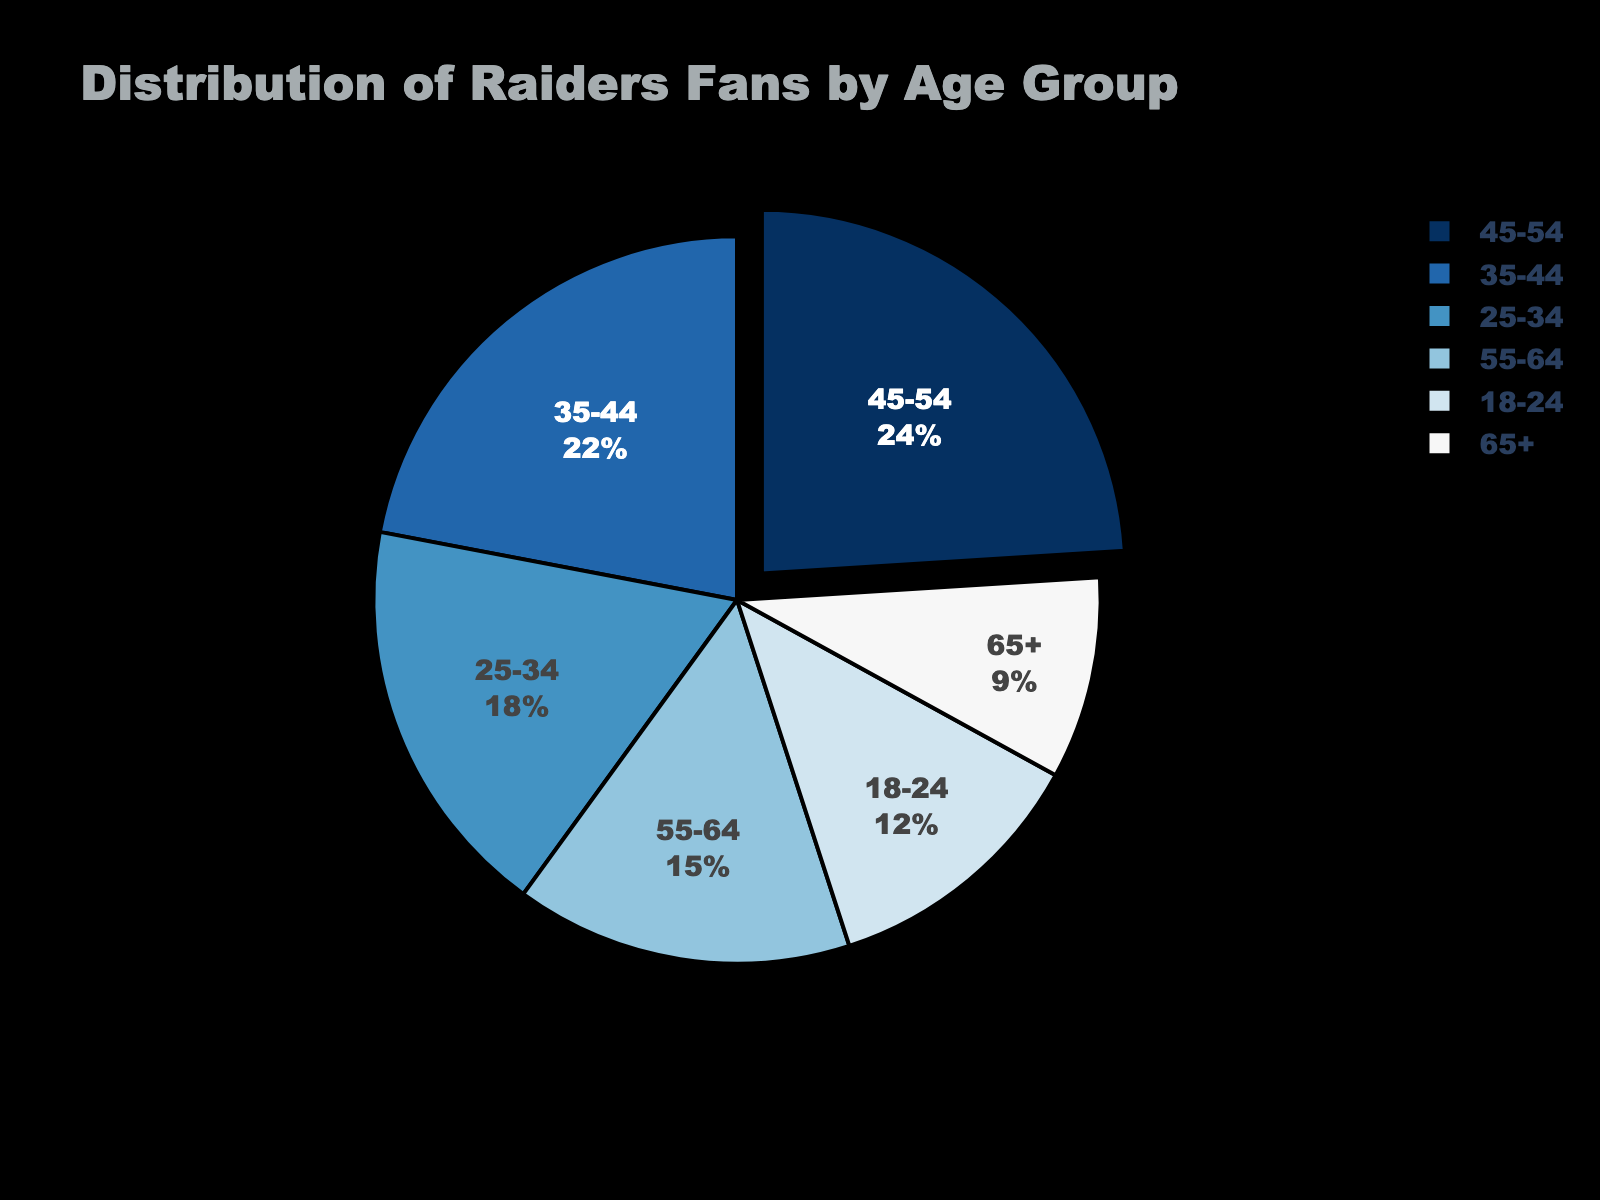What age group has the largest percentage of Raiders fans? By looking at the pie chart, identify the segment with the highest percentage. The age group 45-54 has the largest portion.
Answer: 45-54 What age group has the smallest percentage of Raiders fans? By looking at the pie chart, identify the segment with the smallest percentage. The age group 65+ has the smallest portion.
Answer: 65+ How do the percentages of the age groups 18-24 and 65+ compare? By looking at the pie chart, compare the size of the segments for age groups 18-24 and 65+. The age group 18-24 has a larger percentage than 65+.
Answer: 18-24 > 65+ What is the combined percentage of Raiders fans in the 35-44 and 45-54 age groups? Add the percentages of the 35-44 (22%) and 45-54 (24%) age groups. 22 + 24 = 46%
Answer: 46% Which age group has a percentage closer to the age group 25-34, the 18-24 or the 55-64? By looking at the pie chart, compare percentages: 18-24 is 12%, 25-34 is 18%, and 55-64 is 15%. The age group 55-64 is closer to 25-34 (3% difference) than 18-24 (6% difference).
Answer: 55-64 Which age group has a segment visually distinguished (pulled out) in the pie chart? By observing the pie chart, identify the segment that appears to be pulled out or separated. The age group 45-54 has its segment pulled out to highlight it as the largest group.
Answer: 45-54 How does the percentage of fans aged 45-54 compare to the average percentage of all other age groups combined? Calculate the average percentage of all age groups excluding 45-54. Sum the percentages of the other groups (12 + 18 + 22 + 15 + 9 = 76) and divide by 5. The average is 76/5 = 15.2%. Compare 24% (age 45-54) to 15.2%.
Answer: 45-54 > 15.2% What is the percentage difference between the age groups 45-54 and 18-24? Subtract the percentage of the 18-24 age group (12%) from the 45-54 age group (24%). 24 - 12 = 12%
Answer: 12% 